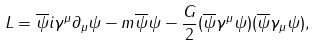<formula> <loc_0><loc_0><loc_500><loc_500>L = \overline { \psi } i \gamma ^ { \mu } \partial _ { \mu } \psi - m \overline { \psi } \psi - \frac { G } { 2 } ( \overline { \psi } \gamma ^ { \mu } \psi ) ( \overline { \psi } \gamma _ { \mu } \psi ) ,</formula> 